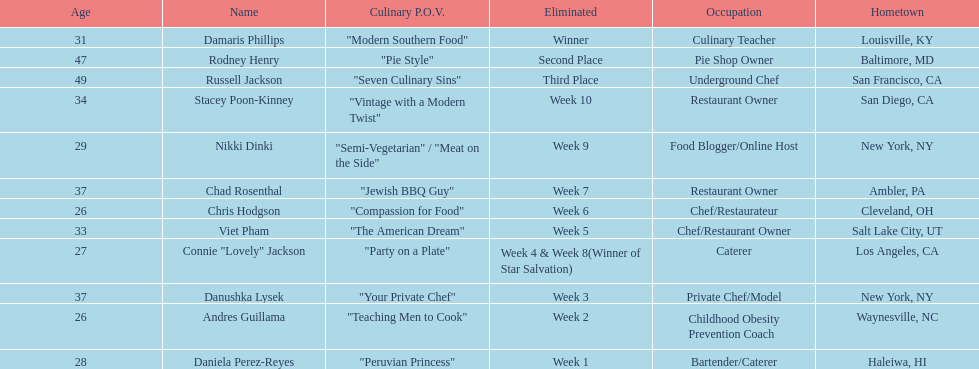Who was the first contestant to be eliminated on season 9 of food network star? Daniela Perez-Reyes. Could you parse the entire table as a dict? {'header': ['Age', 'Name', 'Culinary P.O.V.', 'Eliminated', 'Occupation', 'Hometown'], 'rows': [['31', 'Damaris Phillips', '"Modern Southern Food"', 'Winner', 'Culinary Teacher', 'Louisville, KY'], ['47', 'Rodney Henry', '"Pie Style"', 'Second Place', 'Pie Shop Owner', 'Baltimore, MD'], ['49', 'Russell Jackson', '"Seven Culinary Sins"', 'Third Place', 'Underground Chef', 'San Francisco, CA'], ['34', 'Stacey Poon-Kinney', '"Vintage with a Modern Twist"', 'Week 10', 'Restaurant Owner', 'San Diego, CA'], ['29', 'Nikki Dinki', '"Semi-Vegetarian" / "Meat on the Side"', 'Week 9', 'Food Blogger/Online Host', 'New York, NY'], ['37', 'Chad Rosenthal', '"Jewish BBQ Guy"', 'Week 7', 'Restaurant Owner', 'Ambler, PA'], ['26', 'Chris Hodgson', '"Compassion for Food"', 'Week 6', 'Chef/Restaurateur', 'Cleveland, OH'], ['33', 'Viet Pham', '"The American Dream"', 'Week 5', 'Chef/Restaurant Owner', 'Salt Lake City, UT'], ['27', 'Connie "Lovely" Jackson', '"Party on a Plate"', 'Week 4 & Week 8(Winner of Star Salvation)', 'Caterer', 'Los Angeles, CA'], ['37', 'Danushka Lysek', '"Your Private Chef"', 'Week 3', 'Private Chef/Model', 'New York, NY'], ['26', 'Andres Guillama', '"Teaching Men to Cook"', 'Week 2', 'Childhood Obesity Prevention Coach', 'Waynesville, NC'], ['28', 'Daniela Perez-Reyes', '"Peruvian Princess"', 'Week 1', 'Bartender/Caterer', 'Haleiwa, HI']]} 